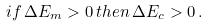Convert formula to latex. <formula><loc_0><loc_0><loc_500><loc_500>i f \, \Delta E _ { m } > 0 \, t h e n \, \Delta E _ { c } > 0 \, .</formula> 